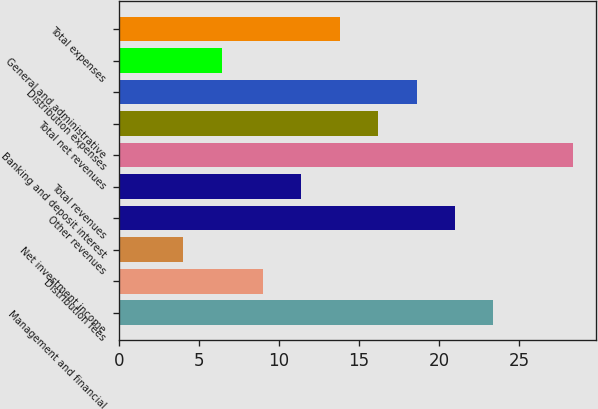Convert chart. <chart><loc_0><loc_0><loc_500><loc_500><bar_chart><fcel>Management and financial<fcel>Distribution fees<fcel>Net investment income<fcel>Other revenues<fcel>Total revenues<fcel>Banking and deposit interest<fcel>Total net revenues<fcel>Distribution expenses<fcel>General and administrative<fcel>Total expenses<nl><fcel>23.4<fcel>9<fcel>4<fcel>21<fcel>11.4<fcel>28.4<fcel>16.2<fcel>18.6<fcel>6.4<fcel>13.8<nl></chart> 